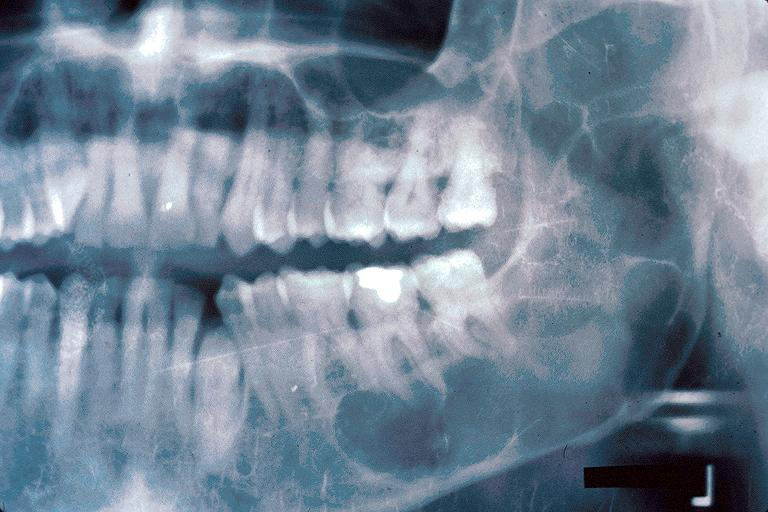what is present?
Answer the question using a single word or phrase. Oral 